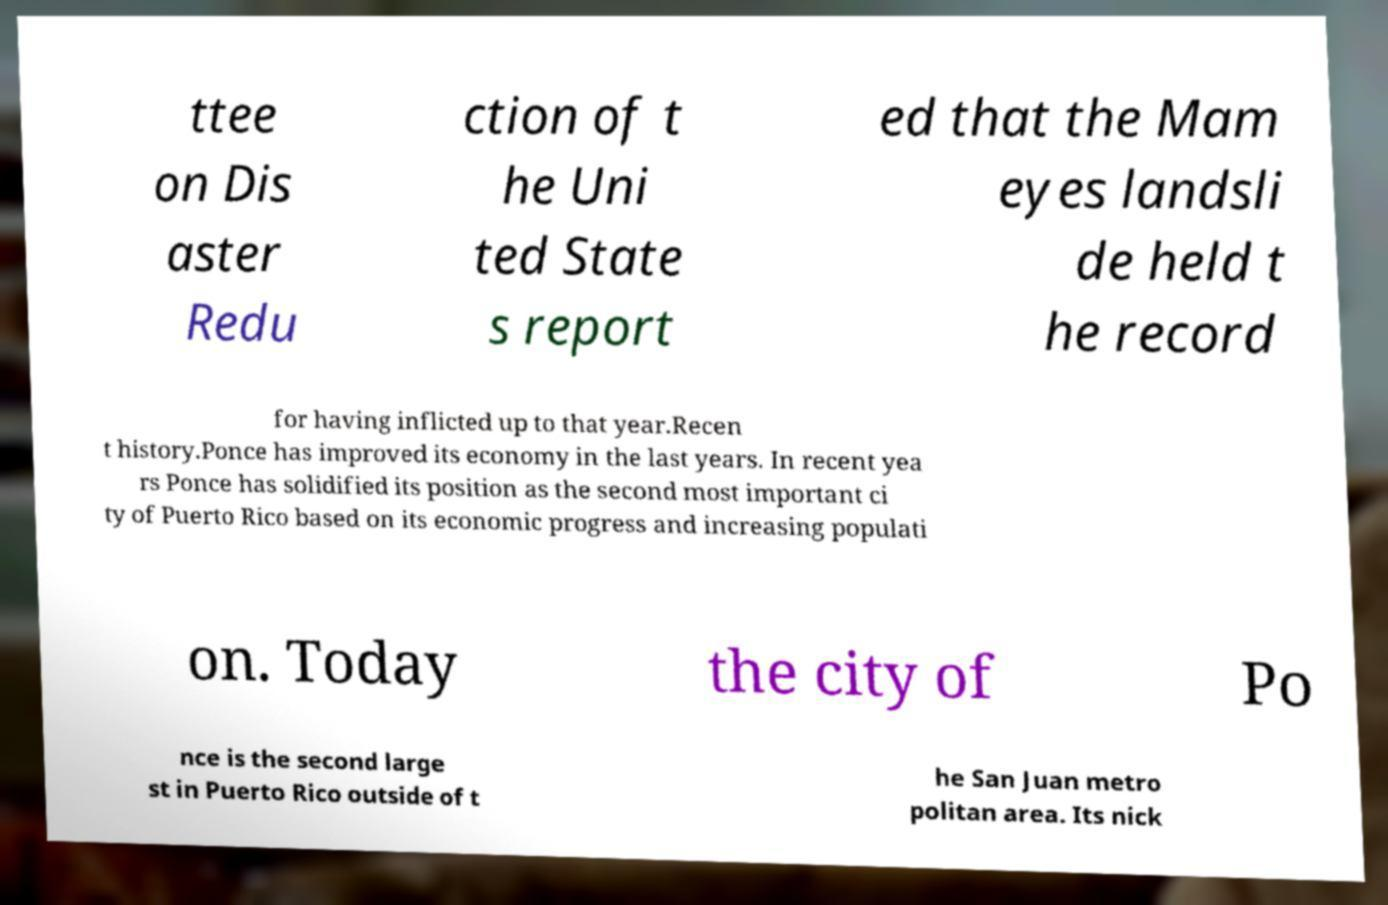For documentation purposes, I need the text within this image transcribed. Could you provide that? ttee on Dis aster Redu ction of t he Uni ted State s report ed that the Mam eyes landsli de held t he record for having inflicted up to that year.Recen t history.Ponce has improved its economy in the last years. In recent yea rs Ponce has solidified its position as the second most important ci ty of Puerto Rico based on its economic progress and increasing populati on. Today the city of Po nce is the second large st in Puerto Rico outside of t he San Juan metro politan area. Its nick 